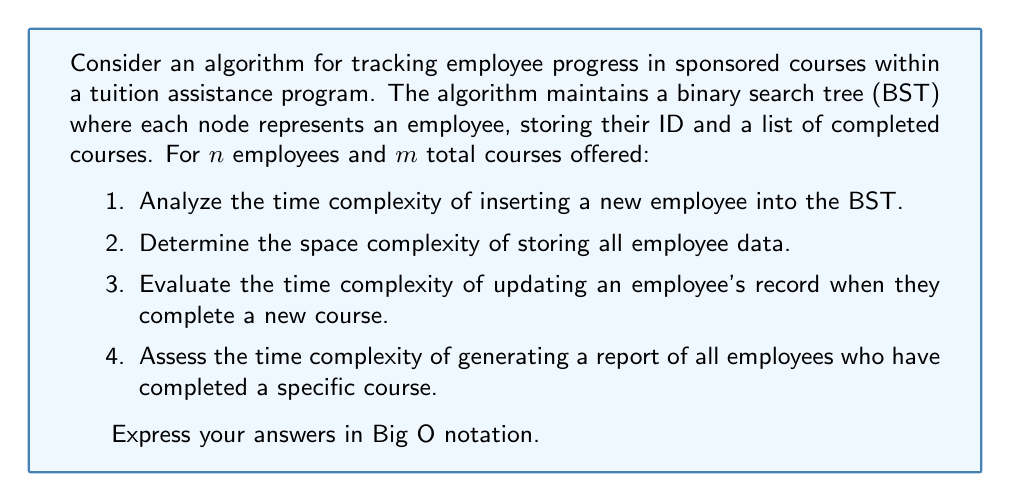Give your solution to this math problem. Let's analyze each part of the question:

1. Inserting a new employee into the BST:
   - In a balanced BST, insertion takes $O(\log n)$ time, where $n$ is the number of employees.
   - However, in the worst case (unbalanced tree), it could take $O(n)$ time.
   - Since we're not guaranteed a balanced tree, we use the worst-case complexity: $O(n)$.

2. Space complexity for storing all employee data:
   - Each employee node contains an ID and a list of completed courses.
   - Space for ID: $O(1)$
   - Space for course list: $O(m)$ in the worst case (if an employee completes all courses)
   - Total space per employee: $O(m)$
   - For $n$ employees: $O(n \cdot m)$

3. Updating an employee's record for a completed course:
   - Finding the employee in the BST: $O(n)$ in the worst case
   - Adding a course to the list: $O(1)$ if using a dynamic array or linked list
   - Total time complexity: $O(n)$

4. Generating a report of employees who completed a specific course:
   - We need to traverse the entire BST: $O(n)$
   - For each employee, check if the course is in their list: $O(m)$ in the worst case
   - Total time complexity: $O(n \cdot m)$
Answer: 1. Time complexity of inserting a new employee: $O(n)$
2. Space complexity of storing all employee data: $O(n \cdot m)$
3. Time complexity of updating an employee's record: $O(n)$
4. Time complexity of generating a course completion report: $O(n \cdot m)$ 